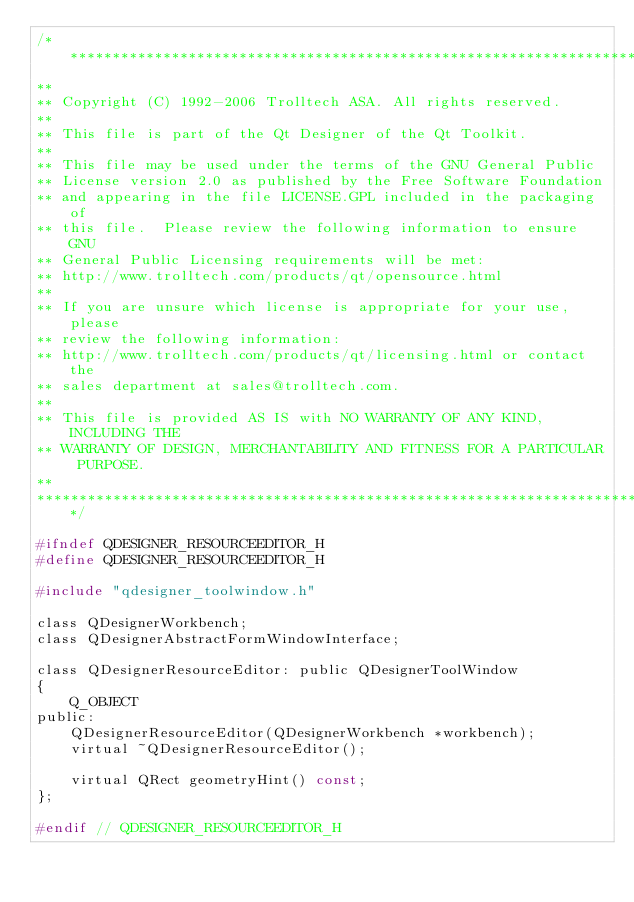Convert code to text. <code><loc_0><loc_0><loc_500><loc_500><_C_>/****************************************************************************
**
** Copyright (C) 1992-2006 Trolltech ASA. All rights reserved.
**
** This file is part of the Qt Designer of the Qt Toolkit.
**
** This file may be used under the terms of the GNU General Public
** License version 2.0 as published by the Free Software Foundation
** and appearing in the file LICENSE.GPL included in the packaging of
** this file.  Please review the following information to ensure GNU
** General Public Licensing requirements will be met:
** http://www.trolltech.com/products/qt/opensource.html
**
** If you are unsure which license is appropriate for your use, please
** review the following information:
** http://www.trolltech.com/products/qt/licensing.html or contact the
** sales department at sales@trolltech.com.
**
** This file is provided AS IS with NO WARRANTY OF ANY KIND, INCLUDING THE
** WARRANTY OF DESIGN, MERCHANTABILITY AND FITNESS FOR A PARTICULAR PURPOSE.
**
****************************************************************************/

#ifndef QDESIGNER_RESOURCEEDITOR_H
#define QDESIGNER_RESOURCEEDITOR_H

#include "qdesigner_toolwindow.h"

class QDesignerWorkbench;
class QDesignerAbstractFormWindowInterface;

class QDesignerResourceEditor: public QDesignerToolWindow
{
    Q_OBJECT
public:
    QDesignerResourceEditor(QDesignerWorkbench *workbench);
    virtual ~QDesignerResourceEditor();

    virtual QRect geometryHint() const;
};

#endif // QDESIGNER_RESOURCEEDITOR_H
</code> 